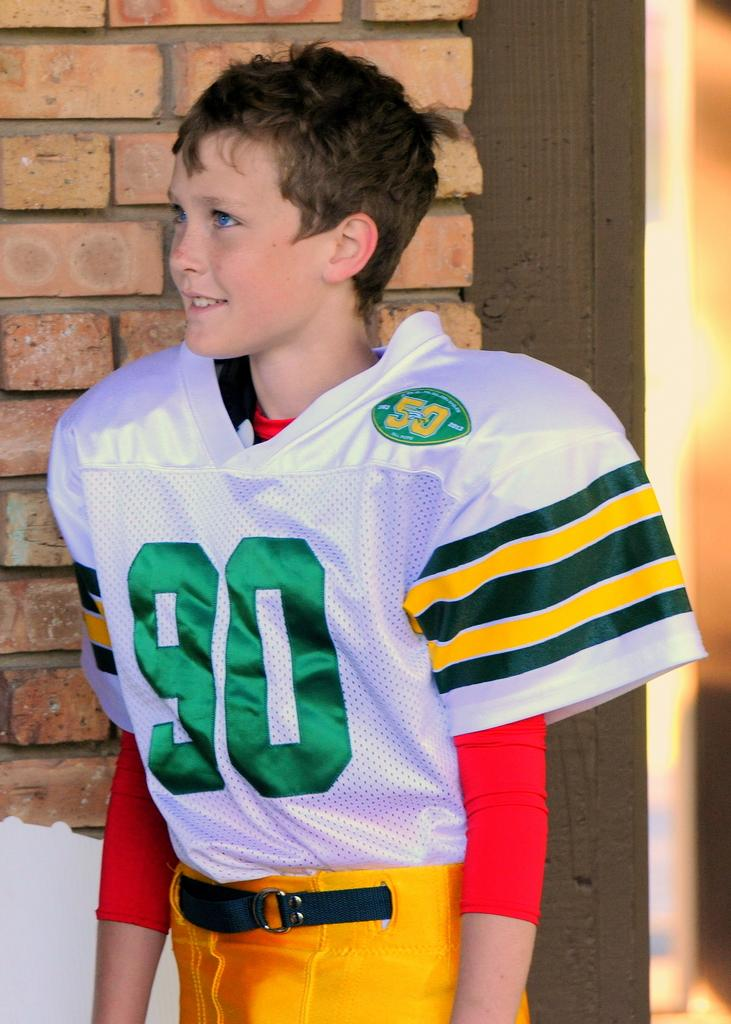<image>
Relay a brief, clear account of the picture shown. Player number 90 wears yellow pants a white and green jersey 